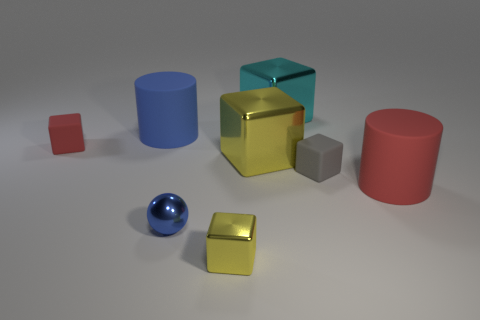What number of things are either red things that are left of the blue rubber thing or objects that are in front of the blue matte cylinder?
Make the answer very short. 6. How many small yellow metallic blocks are behind the shiny thing in front of the blue shiny ball?
Provide a short and direct response. 0. Do the red object behind the big red cylinder and the large cyan object that is behind the metallic ball have the same shape?
Provide a short and direct response. Yes. There is a object that is the same color as the shiny sphere; what is its shape?
Offer a very short reply. Cylinder. Is there a thing that has the same material as the blue ball?
Provide a short and direct response. Yes. How many rubber things are large things or big red cylinders?
Your answer should be compact. 2. There is a matte object that is behind the red matte block left of the tiny blue metal object; what shape is it?
Provide a succinct answer. Cylinder. Is the number of blue cylinders to the left of the blue matte cylinder less than the number of blue matte objects?
Offer a terse response. Yes. What is the shape of the large cyan shiny thing?
Offer a terse response. Cube. There is a red thing that is to the right of the small red cube; what is its size?
Provide a short and direct response. Large. 